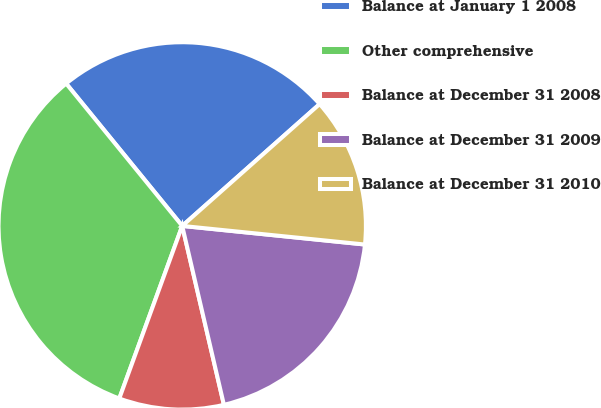Convert chart. <chart><loc_0><loc_0><loc_500><loc_500><pie_chart><fcel>Balance at January 1 2008<fcel>Other comprehensive<fcel>Balance at December 31 2008<fcel>Balance at December 31 2009<fcel>Balance at December 31 2010<nl><fcel>24.34%<fcel>33.55%<fcel>9.21%<fcel>19.74%<fcel>13.16%<nl></chart> 